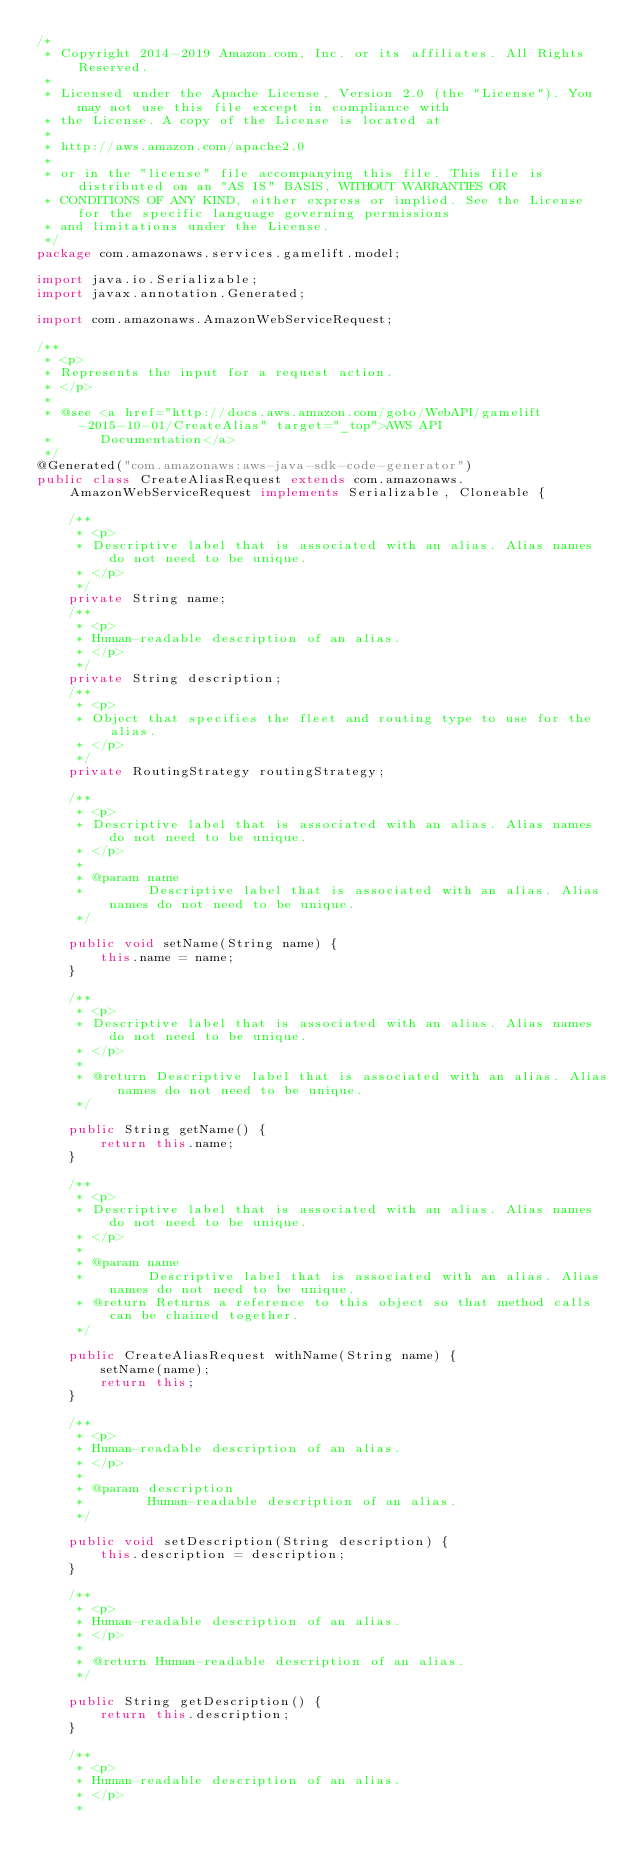Convert code to text. <code><loc_0><loc_0><loc_500><loc_500><_Java_>/*
 * Copyright 2014-2019 Amazon.com, Inc. or its affiliates. All Rights Reserved.
 * 
 * Licensed under the Apache License, Version 2.0 (the "License"). You may not use this file except in compliance with
 * the License. A copy of the License is located at
 * 
 * http://aws.amazon.com/apache2.0
 * 
 * or in the "license" file accompanying this file. This file is distributed on an "AS IS" BASIS, WITHOUT WARRANTIES OR
 * CONDITIONS OF ANY KIND, either express or implied. See the License for the specific language governing permissions
 * and limitations under the License.
 */
package com.amazonaws.services.gamelift.model;

import java.io.Serializable;
import javax.annotation.Generated;

import com.amazonaws.AmazonWebServiceRequest;

/**
 * <p>
 * Represents the input for a request action.
 * </p>
 * 
 * @see <a href="http://docs.aws.amazon.com/goto/WebAPI/gamelift-2015-10-01/CreateAlias" target="_top">AWS API
 *      Documentation</a>
 */
@Generated("com.amazonaws:aws-java-sdk-code-generator")
public class CreateAliasRequest extends com.amazonaws.AmazonWebServiceRequest implements Serializable, Cloneable {

    /**
     * <p>
     * Descriptive label that is associated with an alias. Alias names do not need to be unique.
     * </p>
     */
    private String name;
    /**
     * <p>
     * Human-readable description of an alias.
     * </p>
     */
    private String description;
    /**
     * <p>
     * Object that specifies the fleet and routing type to use for the alias.
     * </p>
     */
    private RoutingStrategy routingStrategy;

    /**
     * <p>
     * Descriptive label that is associated with an alias. Alias names do not need to be unique.
     * </p>
     * 
     * @param name
     *        Descriptive label that is associated with an alias. Alias names do not need to be unique.
     */

    public void setName(String name) {
        this.name = name;
    }

    /**
     * <p>
     * Descriptive label that is associated with an alias. Alias names do not need to be unique.
     * </p>
     * 
     * @return Descriptive label that is associated with an alias. Alias names do not need to be unique.
     */

    public String getName() {
        return this.name;
    }

    /**
     * <p>
     * Descriptive label that is associated with an alias. Alias names do not need to be unique.
     * </p>
     * 
     * @param name
     *        Descriptive label that is associated with an alias. Alias names do not need to be unique.
     * @return Returns a reference to this object so that method calls can be chained together.
     */

    public CreateAliasRequest withName(String name) {
        setName(name);
        return this;
    }

    /**
     * <p>
     * Human-readable description of an alias.
     * </p>
     * 
     * @param description
     *        Human-readable description of an alias.
     */

    public void setDescription(String description) {
        this.description = description;
    }

    /**
     * <p>
     * Human-readable description of an alias.
     * </p>
     * 
     * @return Human-readable description of an alias.
     */

    public String getDescription() {
        return this.description;
    }

    /**
     * <p>
     * Human-readable description of an alias.
     * </p>
     * </code> 